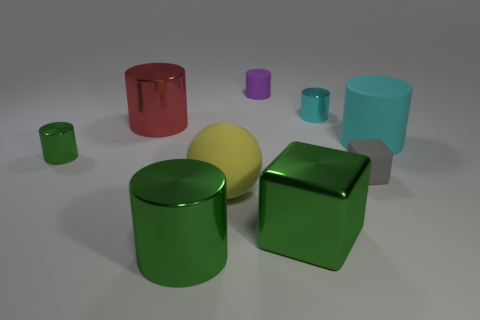Subtract all purple cylinders. How many cylinders are left? 5 Subtract all big cyan matte cylinders. How many cylinders are left? 5 Subtract all yellow cylinders. Subtract all purple spheres. How many cylinders are left? 6 Subtract all spheres. How many objects are left? 8 Subtract 0 red cubes. How many objects are left? 9 Subtract all big cyan rubber cylinders. Subtract all tiny cyan metal things. How many objects are left? 7 Add 2 large cyan matte cylinders. How many large cyan matte cylinders are left? 3 Add 8 large red metallic objects. How many large red metallic objects exist? 9 